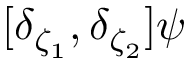<formula> <loc_0><loc_0><loc_500><loc_500>[ \delta _ { \zeta _ { 1 } } , \delta _ { \zeta _ { 2 } } ] \psi</formula> 